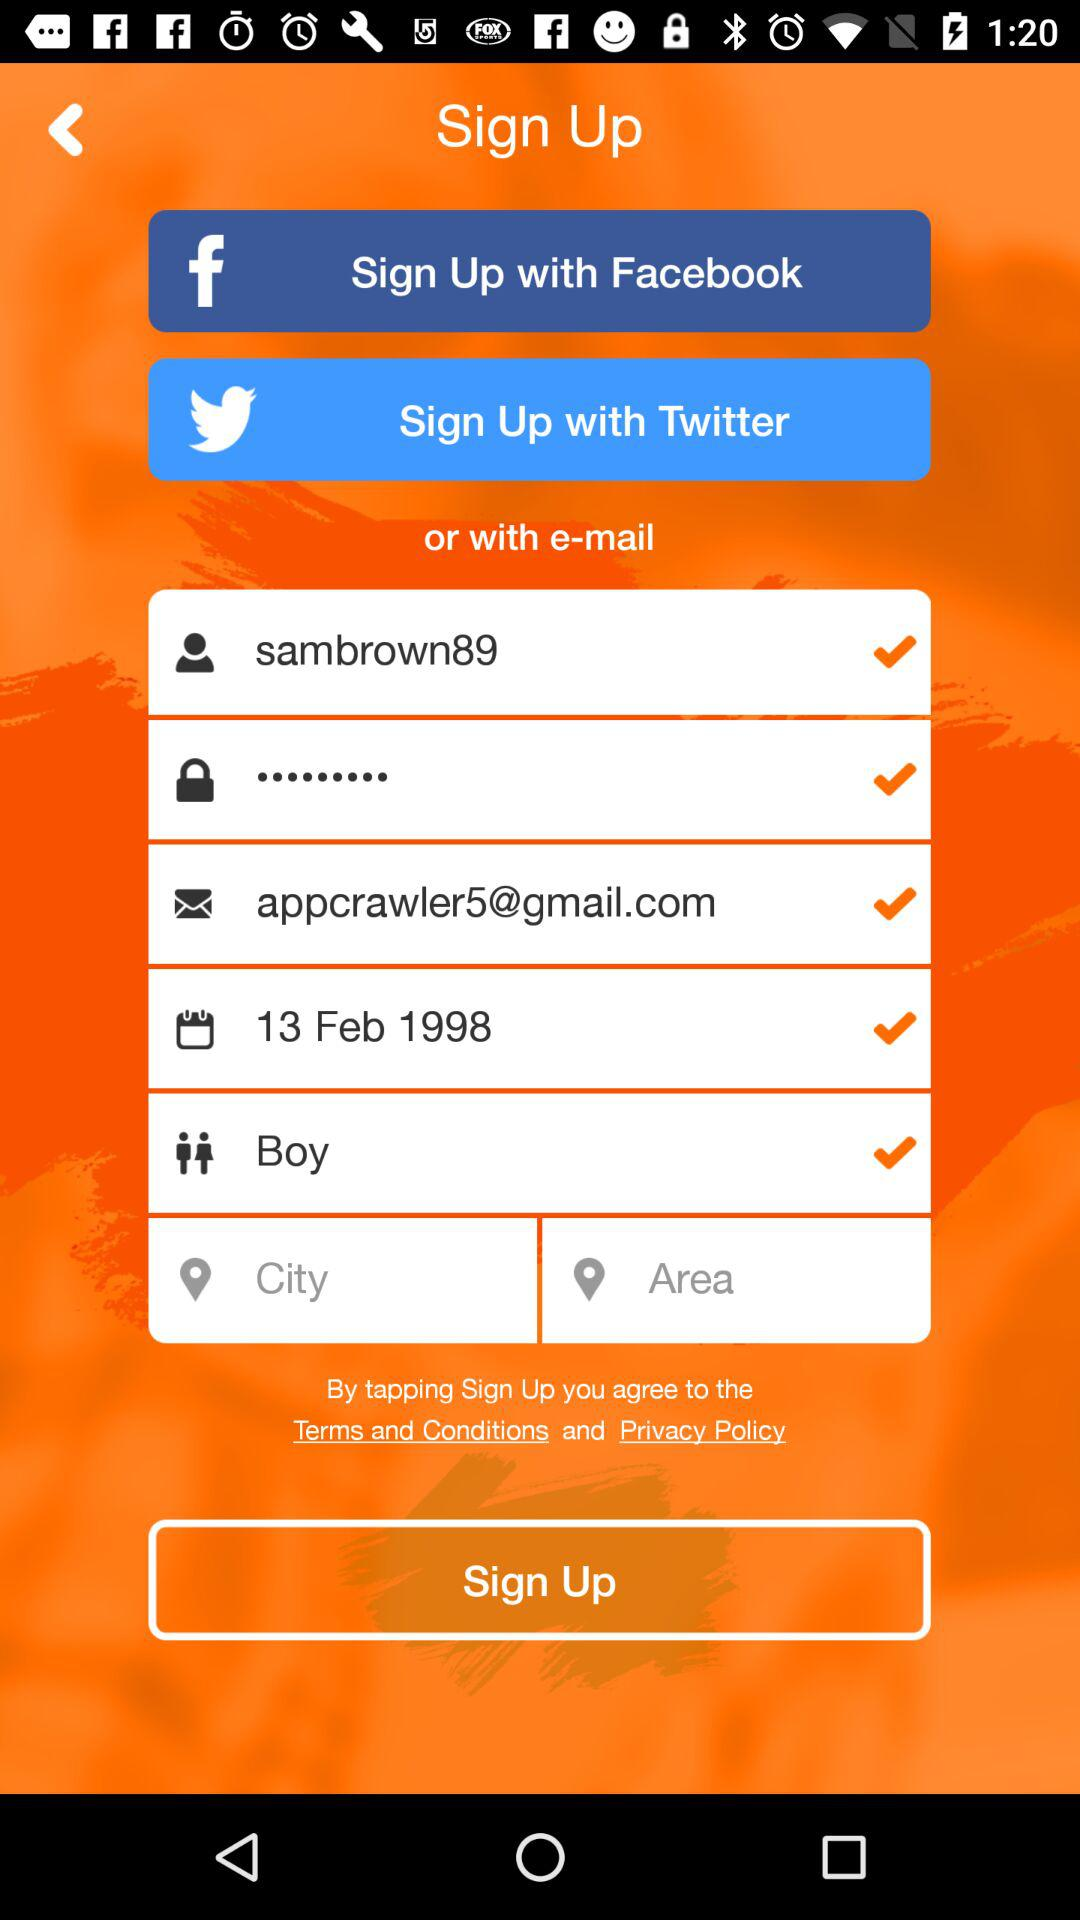How many of the sign up fields have check marks?
Answer the question using a single word or phrase. 5 